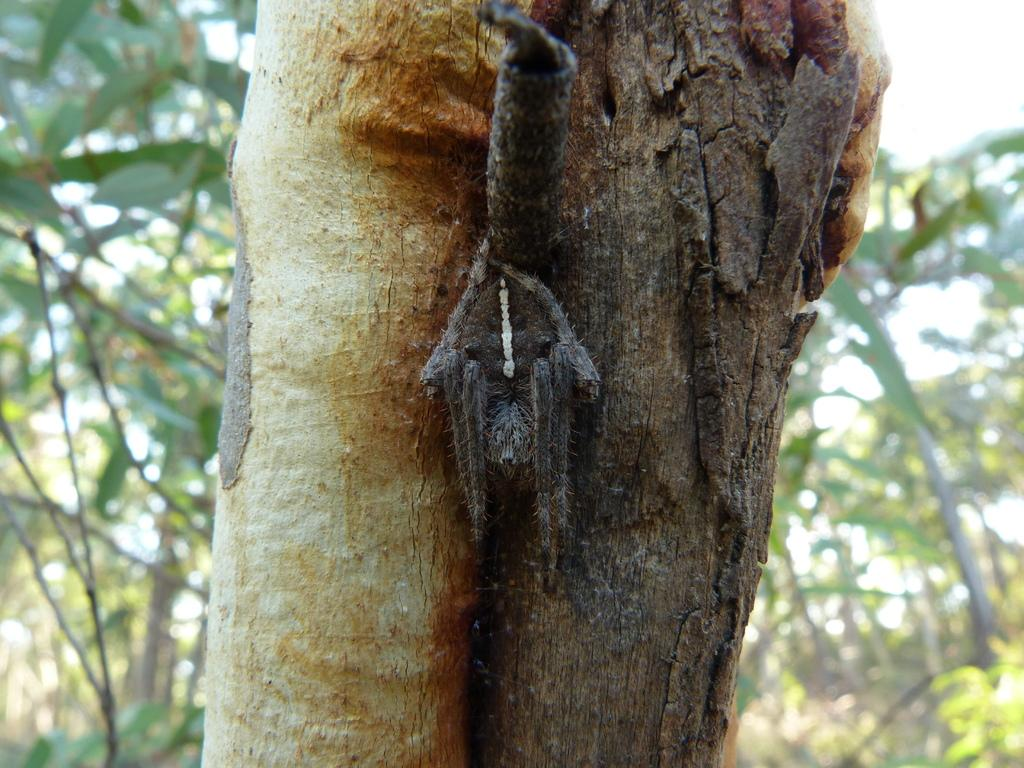What is the main subject of the image? The main subject of the image is the trunk of a tree. Can you describe the surrounding environment in the image? There are trees visible behind the trunk in the image. What type of arithmetic problem is written on the trunk of the tree in the image? There is no arithmetic problem written on the trunk of the tree in the image. Is there a doll sitting on top of the tree trunk in the image? There is no doll present in the image. 